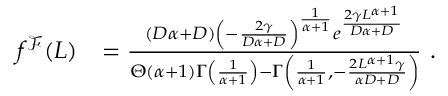Convert formula to latex. <formula><loc_0><loc_0><loc_500><loc_500>\begin{array} { r l } { f ^ { \mathcal { F } } ( L ) } & { = \frac { ( D \alpha + D ) \left ( - \frac { 2 \gamma } { D \alpha + D } \right ) ^ { \frac { 1 } { \alpha + 1 } } e ^ { \frac { 2 \gamma L ^ { \alpha + 1 } } { D \alpha + D } } } { \Theta ( \alpha + 1 ) \Gamma \left ( \frac { 1 } { \alpha + 1 } \right ) - \Gamma \left ( \frac { 1 } { \alpha + 1 } , - \frac { 2 L ^ { \alpha + 1 } \gamma } { \alpha D + D } \right ) } \ . } \end{array}</formula> 